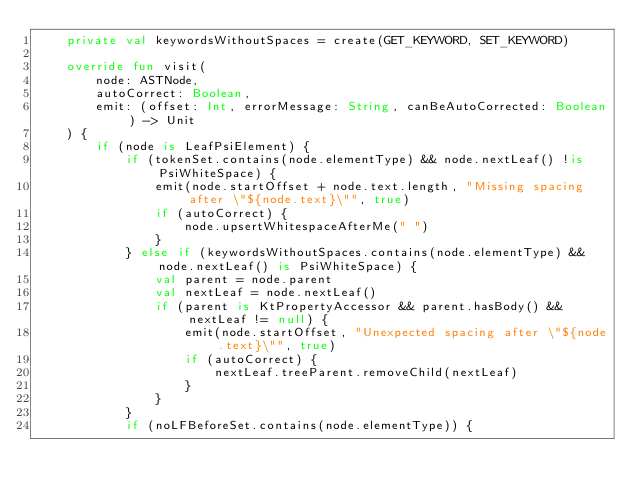Convert code to text. <code><loc_0><loc_0><loc_500><loc_500><_Kotlin_>    private val keywordsWithoutSpaces = create(GET_KEYWORD, SET_KEYWORD)

    override fun visit(
        node: ASTNode,
        autoCorrect: Boolean,
        emit: (offset: Int, errorMessage: String, canBeAutoCorrected: Boolean) -> Unit
    ) {
        if (node is LeafPsiElement) {
            if (tokenSet.contains(node.elementType) && node.nextLeaf() !is PsiWhiteSpace) {
                emit(node.startOffset + node.text.length, "Missing spacing after \"${node.text}\"", true)
                if (autoCorrect) {
                    node.upsertWhitespaceAfterMe(" ")
                }
            } else if (keywordsWithoutSpaces.contains(node.elementType) && node.nextLeaf() is PsiWhiteSpace) {
                val parent = node.parent
                val nextLeaf = node.nextLeaf()
                if (parent is KtPropertyAccessor && parent.hasBody() && nextLeaf != null) {
                    emit(node.startOffset, "Unexpected spacing after \"${node.text}\"", true)
                    if (autoCorrect) {
                        nextLeaf.treeParent.removeChild(nextLeaf)
                    }
                }
            }
            if (noLFBeforeSet.contains(node.elementType)) {</code> 